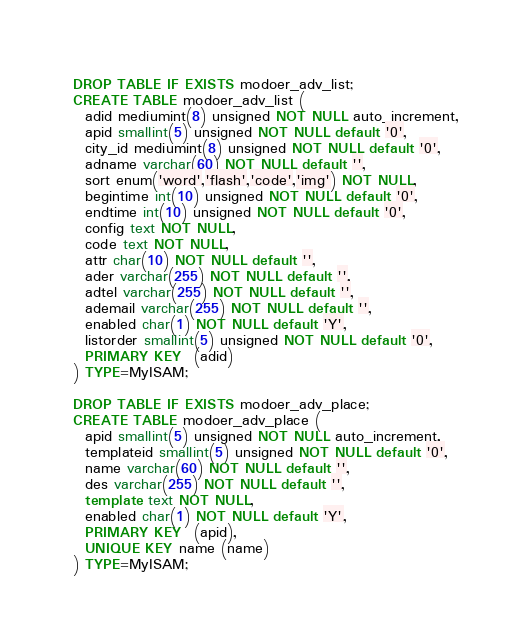<code> <loc_0><loc_0><loc_500><loc_500><_SQL_>DROP TABLE IF EXISTS modoer_adv_list;
CREATE TABLE modoer_adv_list (
  adid mediumint(8) unsigned NOT NULL auto_increment,
  apid smallint(5) unsigned NOT NULL default '0',
  city_id mediumint(8) unsigned NOT NULL default '0',
  adname varchar(60) NOT NULL default '',
  sort enum('word','flash','code','img') NOT NULL,
  begintime int(10) unsigned NOT NULL default '0',
  endtime int(10) unsigned NOT NULL default '0',
  config text NOT NULL,
  code text NOT NULL,
  attr char(10) NOT NULL default '',
  ader varchar(255) NOT NULL default '',
  adtel varchar(255) NOT NULL default '',
  ademail varchar(255) NOT NULL default '',
  enabled char(1) NOT NULL default 'Y',
  listorder smallint(5) unsigned NOT NULL default '0',
  PRIMARY KEY  (adid)
) TYPE=MyISAM;

DROP TABLE IF EXISTS modoer_adv_place;
CREATE TABLE modoer_adv_place (
  apid smallint(5) unsigned NOT NULL auto_increment,
  templateid smallint(5) unsigned NOT NULL default '0',
  name varchar(60) NOT NULL default '',
  des varchar(255) NOT NULL default '',
  template text NOT NULL,
  enabled char(1) NOT NULL default 'Y',
  PRIMARY KEY  (apid),
  UNIQUE KEY name (name)
) TYPE=MyISAM;</code> 